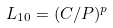Convert formula to latex. <formula><loc_0><loc_0><loc_500><loc_500>L _ { 1 0 } = ( C / P ) ^ { p }</formula> 